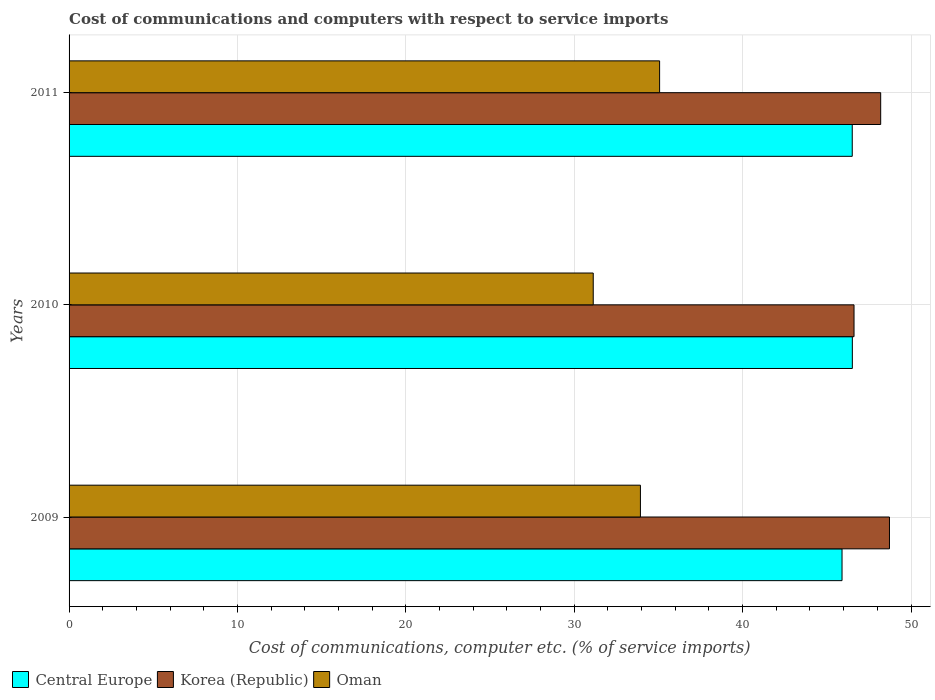How many groups of bars are there?
Keep it short and to the point. 3. Are the number of bars per tick equal to the number of legend labels?
Provide a short and direct response. Yes. How many bars are there on the 1st tick from the top?
Offer a very short reply. 3. How many bars are there on the 2nd tick from the bottom?
Your answer should be very brief. 3. What is the cost of communications and computers in Central Europe in 2010?
Offer a terse response. 46.52. Across all years, what is the maximum cost of communications and computers in Oman?
Your response must be concise. 35.07. Across all years, what is the minimum cost of communications and computers in Korea (Republic)?
Keep it short and to the point. 46.62. In which year was the cost of communications and computers in Oman maximum?
Give a very brief answer. 2011. What is the total cost of communications and computers in Korea (Republic) in the graph?
Ensure brevity in your answer.  143.54. What is the difference between the cost of communications and computers in Korea (Republic) in 2009 and that in 2011?
Offer a very short reply. 0.52. What is the difference between the cost of communications and computers in Central Europe in 2010 and the cost of communications and computers in Oman in 2011?
Ensure brevity in your answer.  11.45. What is the average cost of communications and computers in Central Europe per year?
Keep it short and to the point. 46.31. In the year 2009, what is the difference between the cost of communications and computers in Korea (Republic) and cost of communications and computers in Central Europe?
Give a very brief answer. 2.82. In how many years, is the cost of communications and computers in Oman greater than 40 %?
Keep it short and to the point. 0. What is the ratio of the cost of communications and computers in Korea (Republic) in 2009 to that in 2011?
Offer a terse response. 1.01. Is the cost of communications and computers in Oman in 2010 less than that in 2011?
Provide a short and direct response. Yes. Is the difference between the cost of communications and computers in Korea (Republic) in 2010 and 2011 greater than the difference between the cost of communications and computers in Central Europe in 2010 and 2011?
Your response must be concise. No. What is the difference between the highest and the second highest cost of communications and computers in Oman?
Your response must be concise. 1.14. What is the difference between the highest and the lowest cost of communications and computers in Oman?
Give a very brief answer. 3.94. Is the sum of the cost of communications and computers in Oman in 2010 and 2011 greater than the maximum cost of communications and computers in Central Europe across all years?
Offer a terse response. Yes. What does the 3rd bar from the top in 2010 represents?
Your response must be concise. Central Europe. What does the 1st bar from the bottom in 2009 represents?
Provide a short and direct response. Central Europe. Is it the case that in every year, the sum of the cost of communications and computers in Central Europe and cost of communications and computers in Korea (Republic) is greater than the cost of communications and computers in Oman?
Give a very brief answer. Yes. What is the difference between two consecutive major ticks on the X-axis?
Make the answer very short. 10. Does the graph contain any zero values?
Provide a short and direct response. No. Where does the legend appear in the graph?
Give a very brief answer. Bottom left. How many legend labels are there?
Your answer should be compact. 3. What is the title of the graph?
Your answer should be compact. Cost of communications and computers with respect to service imports. Does "Senegal" appear as one of the legend labels in the graph?
Make the answer very short. No. What is the label or title of the X-axis?
Ensure brevity in your answer.  Cost of communications, computer etc. (% of service imports). What is the label or title of the Y-axis?
Provide a short and direct response. Years. What is the Cost of communications, computer etc. (% of service imports) of Central Europe in 2009?
Your answer should be compact. 45.9. What is the Cost of communications, computer etc. (% of service imports) of Korea (Republic) in 2009?
Offer a terse response. 48.72. What is the Cost of communications, computer etc. (% of service imports) of Oman in 2009?
Your response must be concise. 33.93. What is the Cost of communications, computer etc. (% of service imports) in Central Europe in 2010?
Ensure brevity in your answer.  46.52. What is the Cost of communications, computer etc. (% of service imports) of Korea (Republic) in 2010?
Keep it short and to the point. 46.62. What is the Cost of communications, computer etc. (% of service imports) of Oman in 2010?
Ensure brevity in your answer.  31.13. What is the Cost of communications, computer etc. (% of service imports) in Central Europe in 2011?
Your response must be concise. 46.51. What is the Cost of communications, computer etc. (% of service imports) in Korea (Republic) in 2011?
Your answer should be compact. 48.2. What is the Cost of communications, computer etc. (% of service imports) in Oman in 2011?
Offer a terse response. 35.07. Across all years, what is the maximum Cost of communications, computer etc. (% of service imports) in Central Europe?
Ensure brevity in your answer.  46.52. Across all years, what is the maximum Cost of communications, computer etc. (% of service imports) of Korea (Republic)?
Your answer should be compact. 48.72. Across all years, what is the maximum Cost of communications, computer etc. (% of service imports) in Oman?
Offer a terse response. 35.07. Across all years, what is the minimum Cost of communications, computer etc. (% of service imports) of Central Europe?
Keep it short and to the point. 45.9. Across all years, what is the minimum Cost of communications, computer etc. (% of service imports) of Korea (Republic)?
Offer a very short reply. 46.62. Across all years, what is the minimum Cost of communications, computer etc. (% of service imports) in Oman?
Your answer should be compact. 31.13. What is the total Cost of communications, computer etc. (% of service imports) in Central Europe in the graph?
Your answer should be very brief. 138.93. What is the total Cost of communications, computer etc. (% of service imports) of Korea (Republic) in the graph?
Your response must be concise. 143.54. What is the total Cost of communications, computer etc. (% of service imports) of Oman in the graph?
Make the answer very short. 100.13. What is the difference between the Cost of communications, computer etc. (% of service imports) of Central Europe in 2009 and that in 2010?
Ensure brevity in your answer.  -0.61. What is the difference between the Cost of communications, computer etc. (% of service imports) in Korea (Republic) in 2009 and that in 2010?
Provide a succinct answer. 2.1. What is the difference between the Cost of communications, computer etc. (% of service imports) of Oman in 2009 and that in 2010?
Your response must be concise. 2.8. What is the difference between the Cost of communications, computer etc. (% of service imports) of Central Europe in 2009 and that in 2011?
Provide a short and direct response. -0.61. What is the difference between the Cost of communications, computer etc. (% of service imports) of Korea (Republic) in 2009 and that in 2011?
Provide a short and direct response. 0.52. What is the difference between the Cost of communications, computer etc. (% of service imports) of Oman in 2009 and that in 2011?
Your answer should be very brief. -1.14. What is the difference between the Cost of communications, computer etc. (% of service imports) in Central Europe in 2010 and that in 2011?
Make the answer very short. 0.01. What is the difference between the Cost of communications, computer etc. (% of service imports) of Korea (Republic) in 2010 and that in 2011?
Give a very brief answer. -1.58. What is the difference between the Cost of communications, computer etc. (% of service imports) in Oman in 2010 and that in 2011?
Keep it short and to the point. -3.94. What is the difference between the Cost of communications, computer etc. (% of service imports) of Central Europe in 2009 and the Cost of communications, computer etc. (% of service imports) of Korea (Republic) in 2010?
Give a very brief answer. -0.71. What is the difference between the Cost of communications, computer etc. (% of service imports) in Central Europe in 2009 and the Cost of communications, computer etc. (% of service imports) in Oman in 2010?
Offer a very short reply. 14.77. What is the difference between the Cost of communications, computer etc. (% of service imports) in Korea (Republic) in 2009 and the Cost of communications, computer etc. (% of service imports) in Oman in 2010?
Offer a terse response. 17.59. What is the difference between the Cost of communications, computer etc. (% of service imports) in Central Europe in 2009 and the Cost of communications, computer etc. (% of service imports) in Korea (Republic) in 2011?
Provide a succinct answer. -2.3. What is the difference between the Cost of communications, computer etc. (% of service imports) of Central Europe in 2009 and the Cost of communications, computer etc. (% of service imports) of Oman in 2011?
Ensure brevity in your answer.  10.83. What is the difference between the Cost of communications, computer etc. (% of service imports) of Korea (Republic) in 2009 and the Cost of communications, computer etc. (% of service imports) of Oman in 2011?
Offer a very short reply. 13.65. What is the difference between the Cost of communications, computer etc. (% of service imports) in Central Europe in 2010 and the Cost of communications, computer etc. (% of service imports) in Korea (Republic) in 2011?
Offer a terse response. -1.68. What is the difference between the Cost of communications, computer etc. (% of service imports) of Central Europe in 2010 and the Cost of communications, computer etc. (% of service imports) of Oman in 2011?
Ensure brevity in your answer.  11.45. What is the difference between the Cost of communications, computer etc. (% of service imports) of Korea (Republic) in 2010 and the Cost of communications, computer etc. (% of service imports) of Oman in 2011?
Provide a short and direct response. 11.55. What is the average Cost of communications, computer etc. (% of service imports) of Central Europe per year?
Provide a succinct answer. 46.31. What is the average Cost of communications, computer etc. (% of service imports) in Korea (Republic) per year?
Ensure brevity in your answer.  47.85. What is the average Cost of communications, computer etc. (% of service imports) in Oman per year?
Your answer should be very brief. 33.38. In the year 2009, what is the difference between the Cost of communications, computer etc. (% of service imports) in Central Europe and Cost of communications, computer etc. (% of service imports) in Korea (Republic)?
Offer a very short reply. -2.82. In the year 2009, what is the difference between the Cost of communications, computer etc. (% of service imports) in Central Europe and Cost of communications, computer etc. (% of service imports) in Oman?
Provide a succinct answer. 11.97. In the year 2009, what is the difference between the Cost of communications, computer etc. (% of service imports) in Korea (Republic) and Cost of communications, computer etc. (% of service imports) in Oman?
Keep it short and to the point. 14.79. In the year 2010, what is the difference between the Cost of communications, computer etc. (% of service imports) in Central Europe and Cost of communications, computer etc. (% of service imports) in Korea (Republic)?
Make the answer very short. -0.1. In the year 2010, what is the difference between the Cost of communications, computer etc. (% of service imports) in Central Europe and Cost of communications, computer etc. (% of service imports) in Oman?
Provide a succinct answer. 15.39. In the year 2010, what is the difference between the Cost of communications, computer etc. (% of service imports) of Korea (Republic) and Cost of communications, computer etc. (% of service imports) of Oman?
Make the answer very short. 15.49. In the year 2011, what is the difference between the Cost of communications, computer etc. (% of service imports) of Central Europe and Cost of communications, computer etc. (% of service imports) of Korea (Republic)?
Ensure brevity in your answer.  -1.69. In the year 2011, what is the difference between the Cost of communications, computer etc. (% of service imports) of Central Europe and Cost of communications, computer etc. (% of service imports) of Oman?
Offer a very short reply. 11.44. In the year 2011, what is the difference between the Cost of communications, computer etc. (% of service imports) of Korea (Republic) and Cost of communications, computer etc. (% of service imports) of Oman?
Your response must be concise. 13.13. What is the ratio of the Cost of communications, computer etc. (% of service imports) in Central Europe in 2009 to that in 2010?
Keep it short and to the point. 0.99. What is the ratio of the Cost of communications, computer etc. (% of service imports) of Korea (Republic) in 2009 to that in 2010?
Offer a very short reply. 1.05. What is the ratio of the Cost of communications, computer etc. (% of service imports) of Oman in 2009 to that in 2010?
Provide a short and direct response. 1.09. What is the ratio of the Cost of communications, computer etc. (% of service imports) in Central Europe in 2009 to that in 2011?
Give a very brief answer. 0.99. What is the ratio of the Cost of communications, computer etc. (% of service imports) of Korea (Republic) in 2009 to that in 2011?
Make the answer very short. 1.01. What is the ratio of the Cost of communications, computer etc. (% of service imports) of Oman in 2009 to that in 2011?
Your answer should be compact. 0.97. What is the ratio of the Cost of communications, computer etc. (% of service imports) of Central Europe in 2010 to that in 2011?
Your response must be concise. 1. What is the ratio of the Cost of communications, computer etc. (% of service imports) in Korea (Republic) in 2010 to that in 2011?
Your response must be concise. 0.97. What is the ratio of the Cost of communications, computer etc. (% of service imports) of Oman in 2010 to that in 2011?
Offer a very short reply. 0.89. What is the difference between the highest and the second highest Cost of communications, computer etc. (% of service imports) in Central Europe?
Provide a succinct answer. 0.01. What is the difference between the highest and the second highest Cost of communications, computer etc. (% of service imports) of Korea (Republic)?
Provide a short and direct response. 0.52. What is the difference between the highest and the second highest Cost of communications, computer etc. (% of service imports) of Oman?
Offer a terse response. 1.14. What is the difference between the highest and the lowest Cost of communications, computer etc. (% of service imports) of Central Europe?
Your answer should be very brief. 0.61. What is the difference between the highest and the lowest Cost of communications, computer etc. (% of service imports) in Korea (Republic)?
Your answer should be compact. 2.1. What is the difference between the highest and the lowest Cost of communications, computer etc. (% of service imports) of Oman?
Your response must be concise. 3.94. 